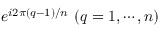Convert formula to latex. <formula><loc_0><loc_0><loc_500><loc_500>e ^ { i 2 \pi ( q - 1 ) / n } ( q = 1 , \cdots , n )</formula> 